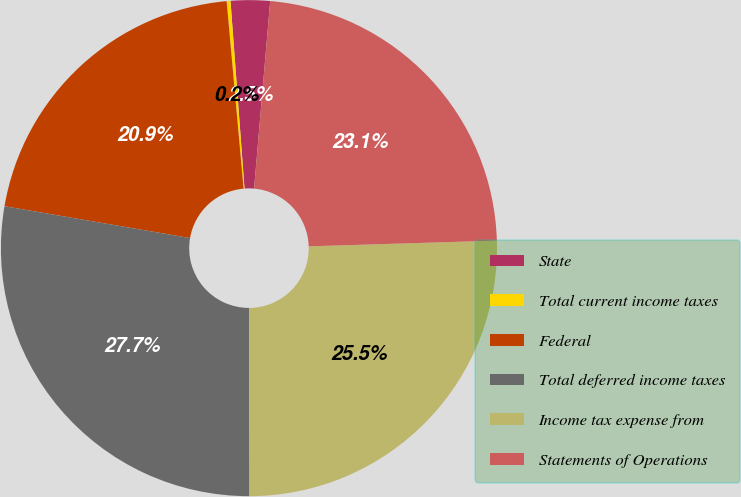<chart> <loc_0><loc_0><loc_500><loc_500><pie_chart><fcel>State<fcel>Total current income taxes<fcel>Federal<fcel>Total deferred income taxes<fcel>Income tax expense from<fcel>Statements of Operations<nl><fcel>2.55%<fcel>0.25%<fcel>20.86%<fcel>27.74%<fcel>25.45%<fcel>23.15%<nl></chart> 